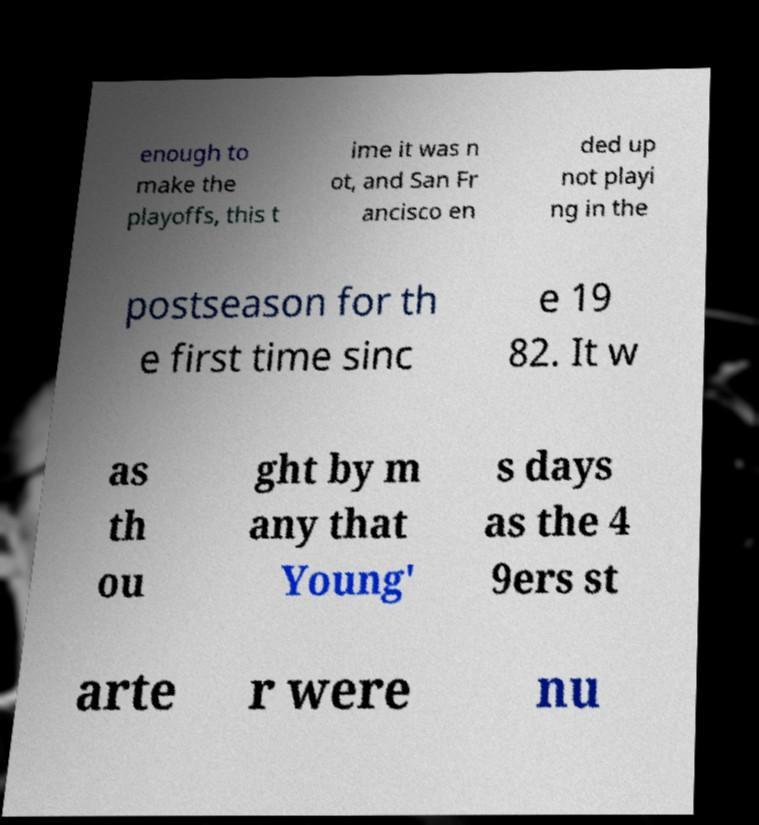Can you accurately transcribe the text from the provided image for me? enough to make the playoffs, this t ime it was n ot, and San Fr ancisco en ded up not playi ng in the postseason for th e first time sinc e 19 82. It w as th ou ght by m any that Young' s days as the 4 9ers st arte r were nu 